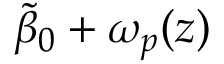<formula> <loc_0><loc_0><loc_500><loc_500>\tilde { \beta } _ { 0 } + \omega _ { p } ( z )</formula> 